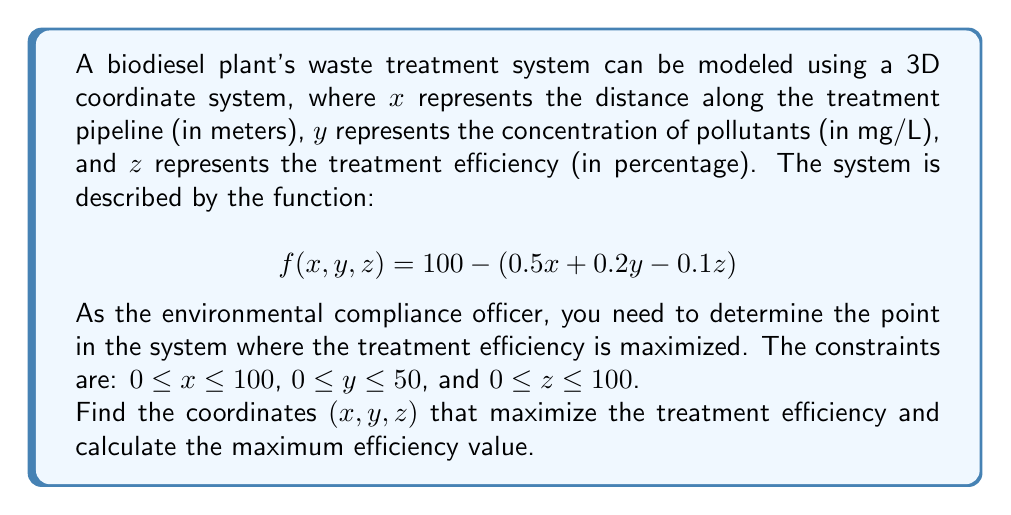Can you answer this question? To solve this problem, we need to follow these steps:

1) The function $f(x,y,z)$ represents the treatment efficiency. We need to maximize this function.

2) Given the constraints, we can see that the function will be maximized when:
   - $x$ is at its minimum (0)
   - $y$ is at its minimum (0)
   - $z$ is at its maximum (100)

This is because:
- Increasing $x$ decreases the function value (coefficient is positive)
- Increasing $y$ decreases the function value (coefficient is positive)
- Increasing $z$ increases the function value (coefficient is negative)

3) Let's substitute these values into the function:

   $$f(0, 0, 100) = 100 - (0.5(0) + 0.2(0) - 0.1(100))$$
   
   $$= 100 - (-10)$$
   
   $$= 110$$

4) Therefore, the maximum efficiency is achieved at the point (0, 0, 100), and the maximum efficiency value is 110%.

5) However, since efficiency cannot exceed 100%, we interpret this result as 100% efficiency at the beginning of the treatment process (x = 0) with no initial pollutants (y = 0) and maximum treatment application (z = 100).
Answer: The coordinates that maximize treatment efficiency are (0, 0, 100), and the maximum efficiency is 100%. 